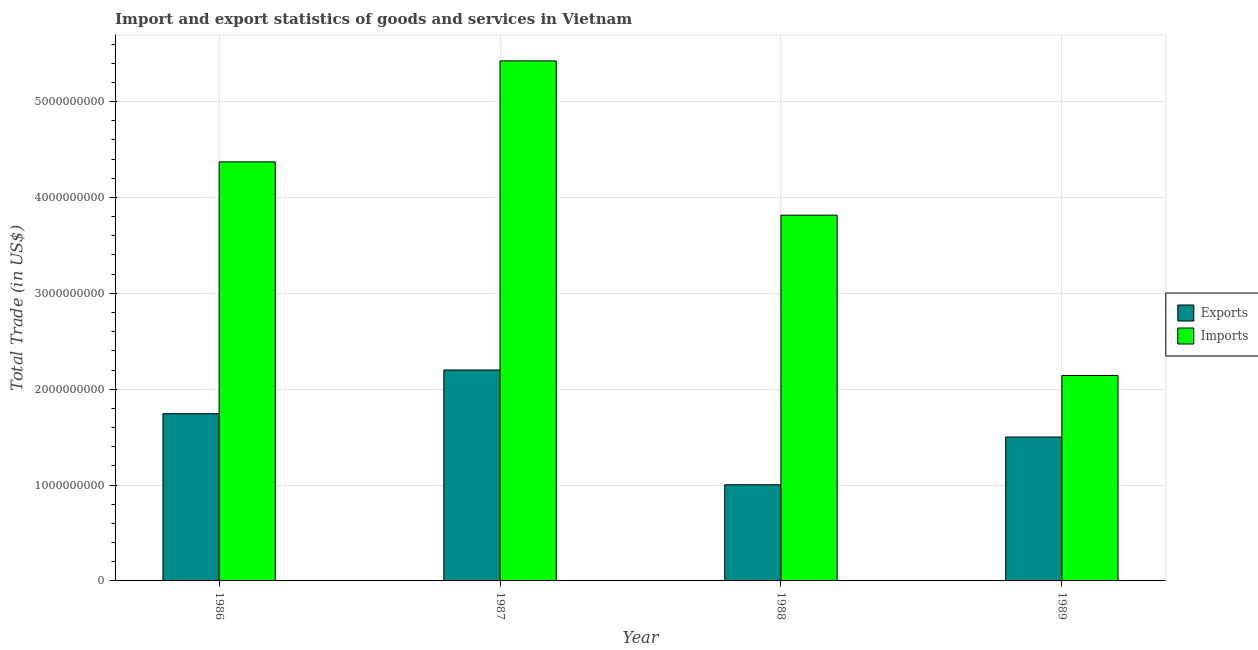How many different coloured bars are there?
Keep it short and to the point. 2. How many bars are there on the 2nd tick from the right?
Your response must be concise. 2. In how many cases, is the number of bars for a given year not equal to the number of legend labels?
Your answer should be very brief. 0. What is the imports of goods and services in 1987?
Offer a very short reply. 5.42e+09. Across all years, what is the maximum imports of goods and services?
Offer a terse response. 5.42e+09. Across all years, what is the minimum imports of goods and services?
Give a very brief answer. 2.14e+09. In which year was the export of goods and services maximum?
Ensure brevity in your answer.  1987. In which year was the export of goods and services minimum?
Give a very brief answer. 1988. What is the total export of goods and services in the graph?
Your answer should be compact. 6.45e+09. What is the difference between the export of goods and services in 1986 and that in 1989?
Offer a terse response. 2.43e+08. What is the difference between the export of goods and services in 1986 and the imports of goods and services in 1987?
Provide a succinct answer. -4.56e+08. What is the average export of goods and services per year?
Give a very brief answer. 1.61e+09. What is the ratio of the export of goods and services in 1986 to that in 1988?
Offer a very short reply. 1.74. Is the imports of goods and services in 1987 less than that in 1988?
Your answer should be compact. No. What is the difference between the highest and the second highest export of goods and services?
Keep it short and to the point. 4.56e+08. What is the difference between the highest and the lowest imports of goods and services?
Your answer should be very brief. 3.28e+09. Is the sum of the export of goods and services in 1986 and 1987 greater than the maximum imports of goods and services across all years?
Offer a very short reply. Yes. What does the 1st bar from the left in 1989 represents?
Provide a short and direct response. Exports. What does the 1st bar from the right in 1989 represents?
Ensure brevity in your answer.  Imports. How many bars are there?
Offer a terse response. 8. How many years are there in the graph?
Offer a terse response. 4. What is the difference between two consecutive major ticks on the Y-axis?
Your answer should be compact. 1.00e+09. Does the graph contain grids?
Offer a very short reply. Yes. How are the legend labels stacked?
Your response must be concise. Vertical. What is the title of the graph?
Keep it short and to the point. Import and export statistics of goods and services in Vietnam. What is the label or title of the X-axis?
Keep it short and to the point. Year. What is the label or title of the Y-axis?
Make the answer very short. Total Trade (in US$). What is the Total Trade (in US$) in Exports in 1986?
Your response must be concise. 1.74e+09. What is the Total Trade (in US$) of Imports in 1986?
Your answer should be very brief. 4.37e+09. What is the Total Trade (in US$) in Exports in 1987?
Your answer should be very brief. 2.20e+09. What is the Total Trade (in US$) of Imports in 1987?
Offer a very short reply. 5.42e+09. What is the Total Trade (in US$) in Exports in 1988?
Make the answer very short. 1.00e+09. What is the Total Trade (in US$) of Imports in 1988?
Your response must be concise. 3.81e+09. What is the Total Trade (in US$) of Exports in 1989?
Keep it short and to the point. 1.50e+09. What is the Total Trade (in US$) in Imports in 1989?
Your response must be concise. 2.14e+09. Across all years, what is the maximum Total Trade (in US$) of Exports?
Offer a terse response. 2.20e+09. Across all years, what is the maximum Total Trade (in US$) of Imports?
Your response must be concise. 5.42e+09. Across all years, what is the minimum Total Trade (in US$) in Exports?
Your answer should be compact. 1.00e+09. Across all years, what is the minimum Total Trade (in US$) of Imports?
Give a very brief answer. 2.14e+09. What is the total Total Trade (in US$) in Exports in the graph?
Offer a terse response. 6.45e+09. What is the total Total Trade (in US$) of Imports in the graph?
Your response must be concise. 1.58e+1. What is the difference between the Total Trade (in US$) in Exports in 1986 and that in 1987?
Keep it short and to the point. -4.56e+08. What is the difference between the Total Trade (in US$) of Imports in 1986 and that in 1987?
Make the answer very short. -1.05e+09. What is the difference between the Total Trade (in US$) of Exports in 1986 and that in 1988?
Your answer should be compact. 7.41e+08. What is the difference between the Total Trade (in US$) of Imports in 1986 and that in 1988?
Make the answer very short. 5.56e+08. What is the difference between the Total Trade (in US$) in Exports in 1986 and that in 1989?
Make the answer very short. 2.43e+08. What is the difference between the Total Trade (in US$) of Imports in 1986 and that in 1989?
Your answer should be very brief. 2.23e+09. What is the difference between the Total Trade (in US$) of Exports in 1987 and that in 1988?
Your response must be concise. 1.20e+09. What is the difference between the Total Trade (in US$) in Imports in 1987 and that in 1988?
Your response must be concise. 1.61e+09. What is the difference between the Total Trade (in US$) of Exports in 1987 and that in 1989?
Provide a succinct answer. 6.99e+08. What is the difference between the Total Trade (in US$) in Imports in 1987 and that in 1989?
Keep it short and to the point. 3.28e+09. What is the difference between the Total Trade (in US$) of Exports in 1988 and that in 1989?
Provide a succinct answer. -4.98e+08. What is the difference between the Total Trade (in US$) in Imports in 1988 and that in 1989?
Provide a short and direct response. 1.67e+09. What is the difference between the Total Trade (in US$) in Exports in 1986 and the Total Trade (in US$) in Imports in 1987?
Ensure brevity in your answer.  -3.68e+09. What is the difference between the Total Trade (in US$) in Exports in 1986 and the Total Trade (in US$) in Imports in 1988?
Your answer should be compact. -2.07e+09. What is the difference between the Total Trade (in US$) in Exports in 1986 and the Total Trade (in US$) in Imports in 1989?
Make the answer very short. -3.99e+08. What is the difference between the Total Trade (in US$) in Exports in 1987 and the Total Trade (in US$) in Imports in 1988?
Your answer should be very brief. -1.61e+09. What is the difference between the Total Trade (in US$) of Exports in 1987 and the Total Trade (in US$) of Imports in 1989?
Give a very brief answer. 5.68e+07. What is the difference between the Total Trade (in US$) of Exports in 1988 and the Total Trade (in US$) of Imports in 1989?
Your answer should be very brief. -1.14e+09. What is the average Total Trade (in US$) in Exports per year?
Offer a very short reply. 1.61e+09. What is the average Total Trade (in US$) in Imports per year?
Offer a very short reply. 3.94e+09. In the year 1986, what is the difference between the Total Trade (in US$) of Exports and Total Trade (in US$) of Imports?
Offer a terse response. -2.63e+09. In the year 1987, what is the difference between the Total Trade (in US$) of Exports and Total Trade (in US$) of Imports?
Your response must be concise. -3.22e+09. In the year 1988, what is the difference between the Total Trade (in US$) in Exports and Total Trade (in US$) in Imports?
Ensure brevity in your answer.  -2.81e+09. In the year 1989, what is the difference between the Total Trade (in US$) in Exports and Total Trade (in US$) in Imports?
Your answer should be very brief. -6.42e+08. What is the ratio of the Total Trade (in US$) in Exports in 1986 to that in 1987?
Keep it short and to the point. 0.79. What is the ratio of the Total Trade (in US$) of Imports in 1986 to that in 1987?
Your answer should be compact. 0.81. What is the ratio of the Total Trade (in US$) in Exports in 1986 to that in 1988?
Offer a terse response. 1.74. What is the ratio of the Total Trade (in US$) of Imports in 1986 to that in 1988?
Provide a succinct answer. 1.15. What is the ratio of the Total Trade (in US$) in Exports in 1986 to that in 1989?
Provide a succinct answer. 1.16. What is the ratio of the Total Trade (in US$) in Imports in 1986 to that in 1989?
Provide a short and direct response. 2.04. What is the ratio of the Total Trade (in US$) of Exports in 1987 to that in 1988?
Keep it short and to the point. 2.19. What is the ratio of the Total Trade (in US$) of Imports in 1987 to that in 1988?
Give a very brief answer. 1.42. What is the ratio of the Total Trade (in US$) of Exports in 1987 to that in 1989?
Provide a succinct answer. 1.47. What is the ratio of the Total Trade (in US$) in Imports in 1987 to that in 1989?
Make the answer very short. 2.53. What is the ratio of the Total Trade (in US$) of Exports in 1988 to that in 1989?
Provide a short and direct response. 0.67. What is the ratio of the Total Trade (in US$) of Imports in 1988 to that in 1989?
Ensure brevity in your answer.  1.78. What is the difference between the highest and the second highest Total Trade (in US$) in Exports?
Offer a terse response. 4.56e+08. What is the difference between the highest and the second highest Total Trade (in US$) of Imports?
Your response must be concise. 1.05e+09. What is the difference between the highest and the lowest Total Trade (in US$) in Exports?
Your answer should be very brief. 1.20e+09. What is the difference between the highest and the lowest Total Trade (in US$) in Imports?
Give a very brief answer. 3.28e+09. 